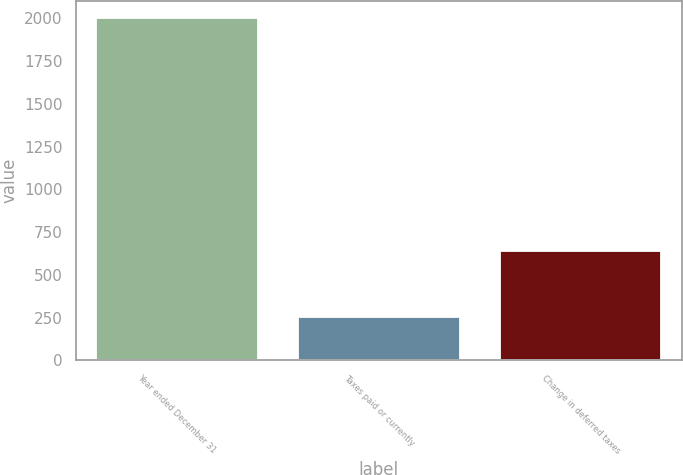<chart> <loc_0><loc_0><loc_500><loc_500><bar_chart><fcel>Year ended December 31<fcel>Taxes paid or currently<fcel>Change in deferred taxes<nl><fcel>2002<fcel>256<fcel>638<nl></chart> 